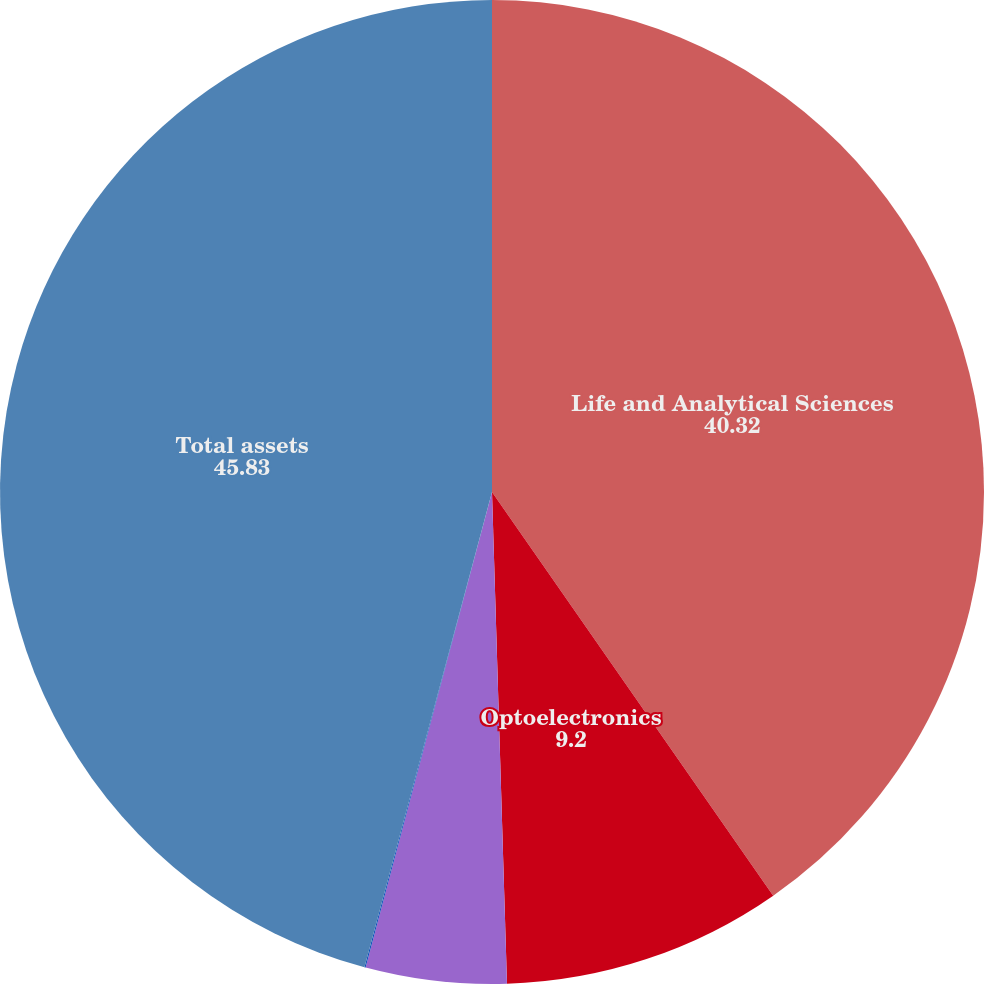Convert chart. <chart><loc_0><loc_0><loc_500><loc_500><pie_chart><fcel>Life and Analytical Sciences<fcel>Optoelectronics<fcel>Corporate<fcel>Net current and long-term<fcel>Total assets<nl><fcel>40.32%<fcel>9.2%<fcel>4.62%<fcel>0.04%<fcel>45.83%<nl></chart> 